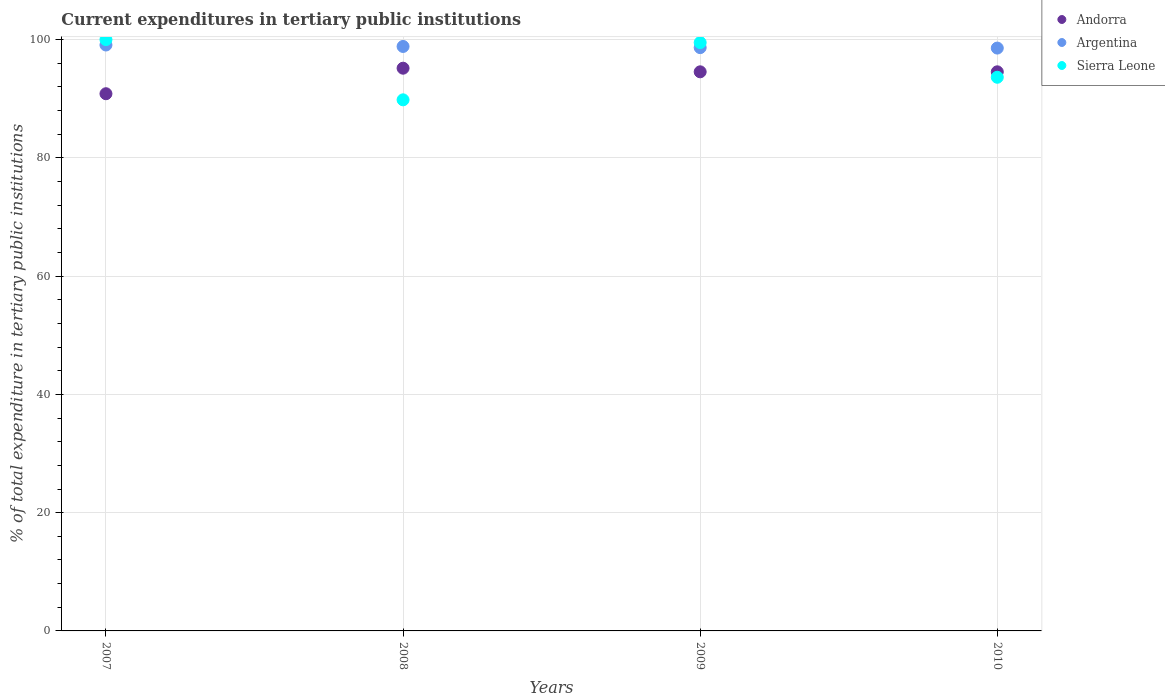What is the current expenditures in tertiary public institutions in Argentina in 2008?
Your answer should be compact. 98.84. Across all years, what is the maximum current expenditures in tertiary public institutions in Argentina?
Ensure brevity in your answer.  99.08. Across all years, what is the minimum current expenditures in tertiary public institutions in Argentina?
Make the answer very short. 98.56. In which year was the current expenditures in tertiary public institutions in Andorra maximum?
Offer a very short reply. 2008. In which year was the current expenditures in tertiary public institutions in Argentina minimum?
Offer a terse response. 2010. What is the total current expenditures in tertiary public institutions in Sierra Leone in the graph?
Ensure brevity in your answer.  382.93. What is the difference between the current expenditures in tertiary public institutions in Sierra Leone in 2009 and that in 2010?
Keep it short and to the point. 5.86. What is the difference between the current expenditures in tertiary public institutions in Andorra in 2007 and the current expenditures in tertiary public institutions in Argentina in 2009?
Make the answer very short. -7.8. What is the average current expenditures in tertiary public institutions in Sierra Leone per year?
Offer a very short reply. 95.73. In the year 2009, what is the difference between the current expenditures in tertiary public institutions in Argentina and current expenditures in tertiary public institutions in Andorra?
Ensure brevity in your answer.  4.09. What is the ratio of the current expenditures in tertiary public institutions in Argentina in 2007 to that in 2009?
Offer a terse response. 1. Is the difference between the current expenditures in tertiary public institutions in Argentina in 2009 and 2010 greater than the difference between the current expenditures in tertiary public institutions in Andorra in 2009 and 2010?
Your answer should be very brief. Yes. What is the difference between the highest and the second highest current expenditures in tertiary public institutions in Andorra?
Keep it short and to the point. 0.61. What is the difference between the highest and the lowest current expenditures in tertiary public institutions in Andorra?
Provide a succinct answer. 4.32. In how many years, is the current expenditures in tertiary public institutions in Argentina greater than the average current expenditures in tertiary public institutions in Argentina taken over all years?
Your answer should be very brief. 2. Does the current expenditures in tertiary public institutions in Andorra monotonically increase over the years?
Your answer should be very brief. No. How many years are there in the graph?
Your response must be concise. 4. Are the values on the major ticks of Y-axis written in scientific E-notation?
Provide a succinct answer. No. Does the graph contain any zero values?
Your answer should be very brief. No. What is the title of the graph?
Keep it short and to the point. Current expenditures in tertiary public institutions. What is the label or title of the Y-axis?
Your answer should be compact. % of total expenditure in tertiary public institutions. What is the % of total expenditure in tertiary public institutions of Andorra in 2007?
Offer a terse response. 90.84. What is the % of total expenditure in tertiary public institutions of Argentina in 2007?
Keep it short and to the point. 99.08. What is the % of total expenditure in tertiary public institutions of Andorra in 2008?
Give a very brief answer. 95.16. What is the % of total expenditure in tertiary public institutions of Argentina in 2008?
Your answer should be compact. 98.84. What is the % of total expenditure in tertiary public institutions of Sierra Leone in 2008?
Offer a very short reply. 89.81. What is the % of total expenditure in tertiary public institutions of Andorra in 2009?
Your response must be concise. 94.55. What is the % of total expenditure in tertiary public institutions of Argentina in 2009?
Your answer should be compact. 98.64. What is the % of total expenditure in tertiary public institutions of Sierra Leone in 2009?
Offer a terse response. 99.49. What is the % of total expenditure in tertiary public institutions in Andorra in 2010?
Provide a succinct answer. 94.55. What is the % of total expenditure in tertiary public institutions in Argentina in 2010?
Offer a terse response. 98.56. What is the % of total expenditure in tertiary public institutions in Sierra Leone in 2010?
Offer a very short reply. 93.63. Across all years, what is the maximum % of total expenditure in tertiary public institutions of Andorra?
Keep it short and to the point. 95.16. Across all years, what is the maximum % of total expenditure in tertiary public institutions of Argentina?
Your answer should be very brief. 99.08. Across all years, what is the maximum % of total expenditure in tertiary public institutions of Sierra Leone?
Offer a terse response. 100. Across all years, what is the minimum % of total expenditure in tertiary public institutions in Andorra?
Keep it short and to the point. 90.84. Across all years, what is the minimum % of total expenditure in tertiary public institutions in Argentina?
Offer a very short reply. 98.56. Across all years, what is the minimum % of total expenditure in tertiary public institutions in Sierra Leone?
Your response must be concise. 89.81. What is the total % of total expenditure in tertiary public institutions of Andorra in the graph?
Offer a very short reply. 375.11. What is the total % of total expenditure in tertiary public institutions in Argentina in the graph?
Ensure brevity in your answer.  395.13. What is the total % of total expenditure in tertiary public institutions of Sierra Leone in the graph?
Provide a short and direct response. 382.93. What is the difference between the % of total expenditure in tertiary public institutions of Andorra in 2007 and that in 2008?
Keep it short and to the point. -4.32. What is the difference between the % of total expenditure in tertiary public institutions in Argentina in 2007 and that in 2008?
Offer a terse response. 0.25. What is the difference between the % of total expenditure in tertiary public institutions in Sierra Leone in 2007 and that in 2008?
Provide a short and direct response. 10.19. What is the difference between the % of total expenditure in tertiary public institutions in Andorra in 2007 and that in 2009?
Your response must be concise. -3.71. What is the difference between the % of total expenditure in tertiary public institutions in Argentina in 2007 and that in 2009?
Your answer should be very brief. 0.44. What is the difference between the % of total expenditure in tertiary public institutions in Sierra Leone in 2007 and that in 2009?
Keep it short and to the point. 0.51. What is the difference between the % of total expenditure in tertiary public institutions in Andorra in 2007 and that in 2010?
Ensure brevity in your answer.  -3.71. What is the difference between the % of total expenditure in tertiary public institutions of Argentina in 2007 and that in 2010?
Ensure brevity in your answer.  0.52. What is the difference between the % of total expenditure in tertiary public institutions in Sierra Leone in 2007 and that in 2010?
Offer a very short reply. 6.37. What is the difference between the % of total expenditure in tertiary public institutions in Andorra in 2008 and that in 2009?
Offer a very short reply. 0.61. What is the difference between the % of total expenditure in tertiary public institutions in Argentina in 2008 and that in 2009?
Offer a terse response. 0.2. What is the difference between the % of total expenditure in tertiary public institutions of Sierra Leone in 2008 and that in 2009?
Your response must be concise. -9.68. What is the difference between the % of total expenditure in tertiary public institutions of Andorra in 2008 and that in 2010?
Keep it short and to the point. 0.61. What is the difference between the % of total expenditure in tertiary public institutions of Argentina in 2008 and that in 2010?
Offer a terse response. 0.27. What is the difference between the % of total expenditure in tertiary public institutions in Sierra Leone in 2008 and that in 2010?
Keep it short and to the point. -3.82. What is the difference between the % of total expenditure in tertiary public institutions in Argentina in 2009 and that in 2010?
Make the answer very short. 0.08. What is the difference between the % of total expenditure in tertiary public institutions in Sierra Leone in 2009 and that in 2010?
Your response must be concise. 5.86. What is the difference between the % of total expenditure in tertiary public institutions in Andorra in 2007 and the % of total expenditure in tertiary public institutions in Argentina in 2008?
Make the answer very short. -7.99. What is the difference between the % of total expenditure in tertiary public institutions of Andorra in 2007 and the % of total expenditure in tertiary public institutions of Sierra Leone in 2008?
Your answer should be compact. 1.03. What is the difference between the % of total expenditure in tertiary public institutions of Argentina in 2007 and the % of total expenditure in tertiary public institutions of Sierra Leone in 2008?
Offer a terse response. 9.27. What is the difference between the % of total expenditure in tertiary public institutions of Andorra in 2007 and the % of total expenditure in tertiary public institutions of Argentina in 2009?
Offer a very short reply. -7.8. What is the difference between the % of total expenditure in tertiary public institutions in Andorra in 2007 and the % of total expenditure in tertiary public institutions in Sierra Leone in 2009?
Your response must be concise. -8.65. What is the difference between the % of total expenditure in tertiary public institutions in Argentina in 2007 and the % of total expenditure in tertiary public institutions in Sierra Leone in 2009?
Provide a short and direct response. -0.41. What is the difference between the % of total expenditure in tertiary public institutions in Andorra in 2007 and the % of total expenditure in tertiary public institutions in Argentina in 2010?
Your answer should be very brief. -7.72. What is the difference between the % of total expenditure in tertiary public institutions in Andorra in 2007 and the % of total expenditure in tertiary public institutions in Sierra Leone in 2010?
Your answer should be very brief. -2.79. What is the difference between the % of total expenditure in tertiary public institutions of Argentina in 2007 and the % of total expenditure in tertiary public institutions of Sierra Leone in 2010?
Give a very brief answer. 5.45. What is the difference between the % of total expenditure in tertiary public institutions in Andorra in 2008 and the % of total expenditure in tertiary public institutions in Argentina in 2009?
Keep it short and to the point. -3.48. What is the difference between the % of total expenditure in tertiary public institutions in Andorra in 2008 and the % of total expenditure in tertiary public institutions in Sierra Leone in 2009?
Offer a very short reply. -4.33. What is the difference between the % of total expenditure in tertiary public institutions of Argentina in 2008 and the % of total expenditure in tertiary public institutions of Sierra Leone in 2009?
Your answer should be very brief. -0.65. What is the difference between the % of total expenditure in tertiary public institutions of Andorra in 2008 and the % of total expenditure in tertiary public institutions of Argentina in 2010?
Your response must be concise. -3.4. What is the difference between the % of total expenditure in tertiary public institutions of Andorra in 2008 and the % of total expenditure in tertiary public institutions of Sierra Leone in 2010?
Offer a terse response. 1.53. What is the difference between the % of total expenditure in tertiary public institutions of Argentina in 2008 and the % of total expenditure in tertiary public institutions of Sierra Leone in 2010?
Provide a short and direct response. 5.21. What is the difference between the % of total expenditure in tertiary public institutions in Andorra in 2009 and the % of total expenditure in tertiary public institutions in Argentina in 2010?
Keep it short and to the point. -4.01. What is the difference between the % of total expenditure in tertiary public institutions in Andorra in 2009 and the % of total expenditure in tertiary public institutions in Sierra Leone in 2010?
Make the answer very short. 0.92. What is the difference between the % of total expenditure in tertiary public institutions in Argentina in 2009 and the % of total expenditure in tertiary public institutions in Sierra Leone in 2010?
Your answer should be compact. 5.01. What is the average % of total expenditure in tertiary public institutions in Andorra per year?
Provide a succinct answer. 93.78. What is the average % of total expenditure in tertiary public institutions in Argentina per year?
Provide a short and direct response. 98.78. What is the average % of total expenditure in tertiary public institutions of Sierra Leone per year?
Make the answer very short. 95.73. In the year 2007, what is the difference between the % of total expenditure in tertiary public institutions in Andorra and % of total expenditure in tertiary public institutions in Argentina?
Offer a very short reply. -8.24. In the year 2007, what is the difference between the % of total expenditure in tertiary public institutions of Andorra and % of total expenditure in tertiary public institutions of Sierra Leone?
Your answer should be compact. -9.16. In the year 2007, what is the difference between the % of total expenditure in tertiary public institutions in Argentina and % of total expenditure in tertiary public institutions in Sierra Leone?
Offer a terse response. -0.92. In the year 2008, what is the difference between the % of total expenditure in tertiary public institutions in Andorra and % of total expenditure in tertiary public institutions in Argentina?
Provide a succinct answer. -3.68. In the year 2008, what is the difference between the % of total expenditure in tertiary public institutions in Andorra and % of total expenditure in tertiary public institutions in Sierra Leone?
Offer a very short reply. 5.35. In the year 2008, what is the difference between the % of total expenditure in tertiary public institutions of Argentina and % of total expenditure in tertiary public institutions of Sierra Leone?
Make the answer very short. 9.03. In the year 2009, what is the difference between the % of total expenditure in tertiary public institutions in Andorra and % of total expenditure in tertiary public institutions in Argentina?
Ensure brevity in your answer.  -4.09. In the year 2009, what is the difference between the % of total expenditure in tertiary public institutions in Andorra and % of total expenditure in tertiary public institutions in Sierra Leone?
Make the answer very short. -4.94. In the year 2009, what is the difference between the % of total expenditure in tertiary public institutions in Argentina and % of total expenditure in tertiary public institutions in Sierra Leone?
Your answer should be compact. -0.85. In the year 2010, what is the difference between the % of total expenditure in tertiary public institutions of Andorra and % of total expenditure in tertiary public institutions of Argentina?
Offer a terse response. -4.01. In the year 2010, what is the difference between the % of total expenditure in tertiary public institutions in Andorra and % of total expenditure in tertiary public institutions in Sierra Leone?
Provide a succinct answer. 0.92. In the year 2010, what is the difference between the % of total expenditure in tertiary public institutions of Argentina and % of total expenditure in tertiary public institutions of Sierra Leone?
Make the answer very short. 4.93. What is the ratio of the % of total expenditure in tertiary public institutions in Andorra in 2007 to that in 2008?
Your answer should be very brief. 0.95. What is the ratio of the % of total expenditure in tertiary public institutions in Sierra Leone in 2007 to that in 2008?
Your response must be concise. 1.11. What is the ratio of the % of total expenditure in tertiary public institutions in Andorra in 2007 to that in 2009?
Provide a succinct answer. 0.96. What is the ratio of the % of total expenditure in tertiary public institutions of Sierra Leone in 2007 to that in 2009?
Provide a short and direct response. 1.01. What is the ratio of the % of total expenditure in tertiary public institutions of Andorra in 2007 to that in 2010?
Ensure brevity in your answer.  0.96. What is the ratio of the % of total expenditure in tertiary public institutions in Sierra Leone in 2007 to that in 2010?
Your answer should be very brief. 1.07. What is the ratio of the % of total expenditure in tertiary public institutions of Sierra Leone in 2008 to that in 2009?
Give a very brief answer. 0.9. What is the ratio of the % of total expenditure in tertiary public institutions of Andorra in 2008 to that in 2010?
Your response must be concise. 1.01. What is the ratio of the % of total expenditure in tertiary public institutions in Argentina in 2008 to that in 2010?
Keep it short and to the point. 1. What is the ratio of the % of total expenditure in tertiary public institutions in Sierra Leone in 2008 to that in 2010?
Provide a succinct answer. 0.96. What is the ratio of the % of total expenditure in tertiary public institutions in Andorra in 2009 to that in 2010?
Your answer should be compact. 1. What is the ratio of the % of total expenditure in tertiary public institutions of Sierra Leone in 2009 to that in 2010?
Your response must be concise. 1.06. What is the difference between the highest and the second highest % of total expenditure in tertiary public institutions of Andorra?
Offer a very short reply. 0.61. What is the difference between the highest and the second highest % of total expenditure in tertiary public institutions in Argentina?
Give a very brief answer. 0.25. What is the difference between the highest and the second highest % of total expenditure in tertiary public institutions in Sierra Leone?
Ensure brevity in your answer.  0.51. What is the difference between the highest and the lowest % of total expenditure in tertiary public institutions in Andorra?
Your response must be concise. 4.32. What is the difference between the highest and the lowest % of total expenditure in tertiary public institutions of Argentina?
Offer a terse response. 0.52. What is the difference between the highest and the lowest % of total expenditure in tertiary public institutions in Sierra Leone?
Provide a short and direct response. 10.19. 